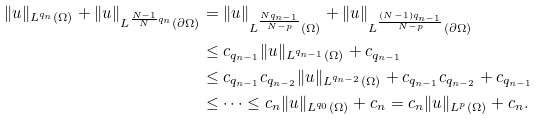<formula> <loc_0><loc_0><loc_500><loc_500>\| u \| _ { L ^ { q _ { n } } ( \Omega ) } + \| u \| _ { L ^ { \frac { N - 1 } { N } q _ { n } } ( \partial \Omega ) } & = \| u \| _ { L ^ { \frac { N q _ { n - 1 } } { N - p } } ( \Omega ) } + \| u \| _ { L ^ { \frac { ( N - 1 ) q _ { n - 1 } } { N - p } } ( \partial \Omega ) } \\ & \leq c _ { q _ { n - 1 } } \| u \| _ { L ^ { q _ { n - 1 } } ( \Omega ) } + c _ { q _ { n - 1 } } \\ & \leq c _ { q _ { n - 1 } } c _ { q _ { n - 2 } } \| u \| _ { L ^ { q _ { n - 2 } } ( \Omega ) } + c _ { q _ { n - 1 } } c _ { q _ { n - 2 } } + c _ { q _ { n - 1 } } \\ & \leq \cdots \leq c _ { n } \| u \| _ { L ^ { q _ { 0 } } ( \Omega ) } + c _ { n } = c _ { n } \| u \| _ { L ^ { p } ( \Omega ) } + c _ { n } .</formula> 